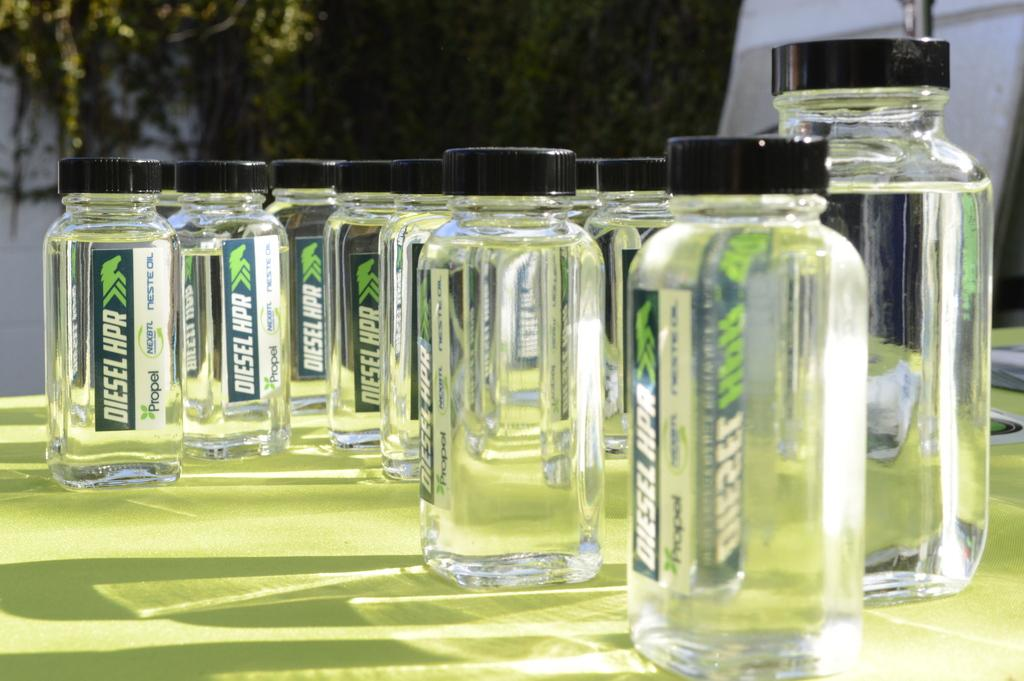<image>
Provide a brief description of the given image. Several glass jars with Diesel hpr printed on them 